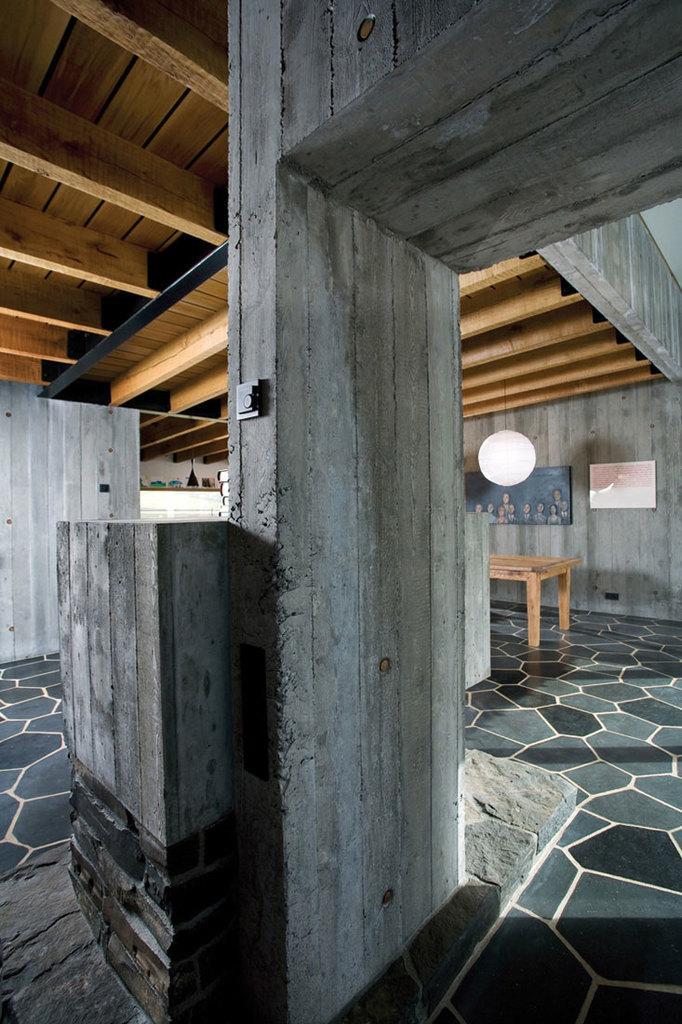Please provide a concise description of this image. This picture is an inside view of a room. In this picture we can see the wall, table, boards, lantern, pillar, circuit board. At the bottom of the image we can see the floor. At the top of the image we can see the roof. 